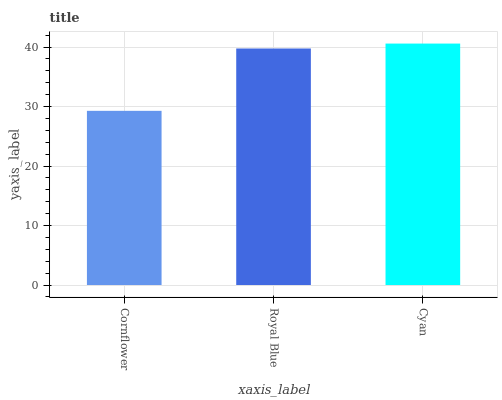Is Cornflower the minimum?
Answer yes or no. Yes. Is Cyan the maximum?
Answer yes or no. Yes. Is Royal Blue the minimum?
Answer yes or no. No. Is Royal Blue the maximum?
Answer yes or no. No. Is Royal Blue greater than Cornflower?
Answer yes or no. Yes. Is Cornflower less than Royal Blue?
Answer yes or no. Yes. Is Cornflower greater than Royal Blue?
Answer yes or no. No. Is Royal Blue less than Cornflower?
Answer yes or no. No. Is Royal Blue the high median?
Answer yes or no. Yes. Is Royal Blue the low median?
Answer yes or no. Yes. Is Cyan the high median?
Answer yes or no. No. Is Cyan the low median?
Answer yes or no. No. 